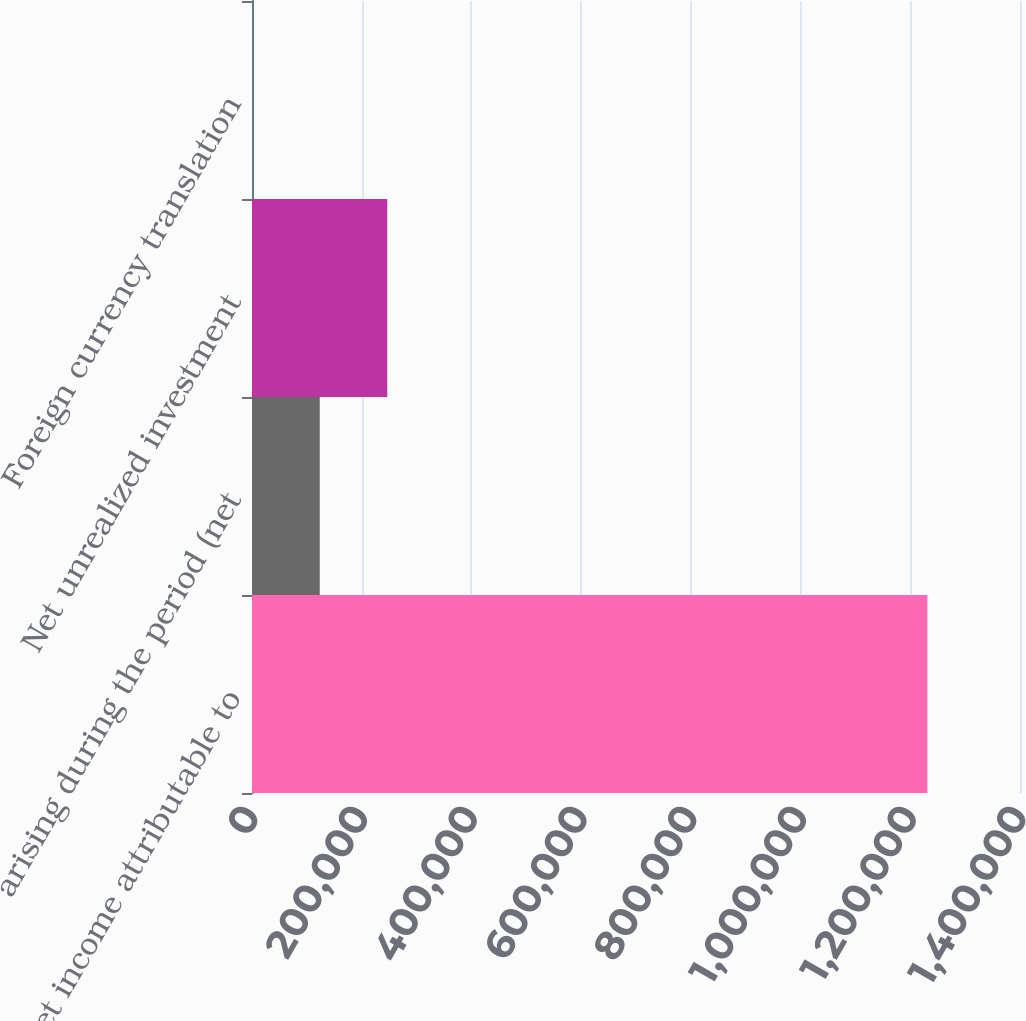Convert chart to OTSL. <chart><loc_0><loc_0><loc_500><loc_500><bar_chart><fcel>Net income attributable to<fcel>arising during the period (net<fcel>Net unrealized investment<fcel>Foreign currency translation<nl><fcel>1.23109e+06<fcel>123520<fcel>246584<fcel>457<nl></chart> 